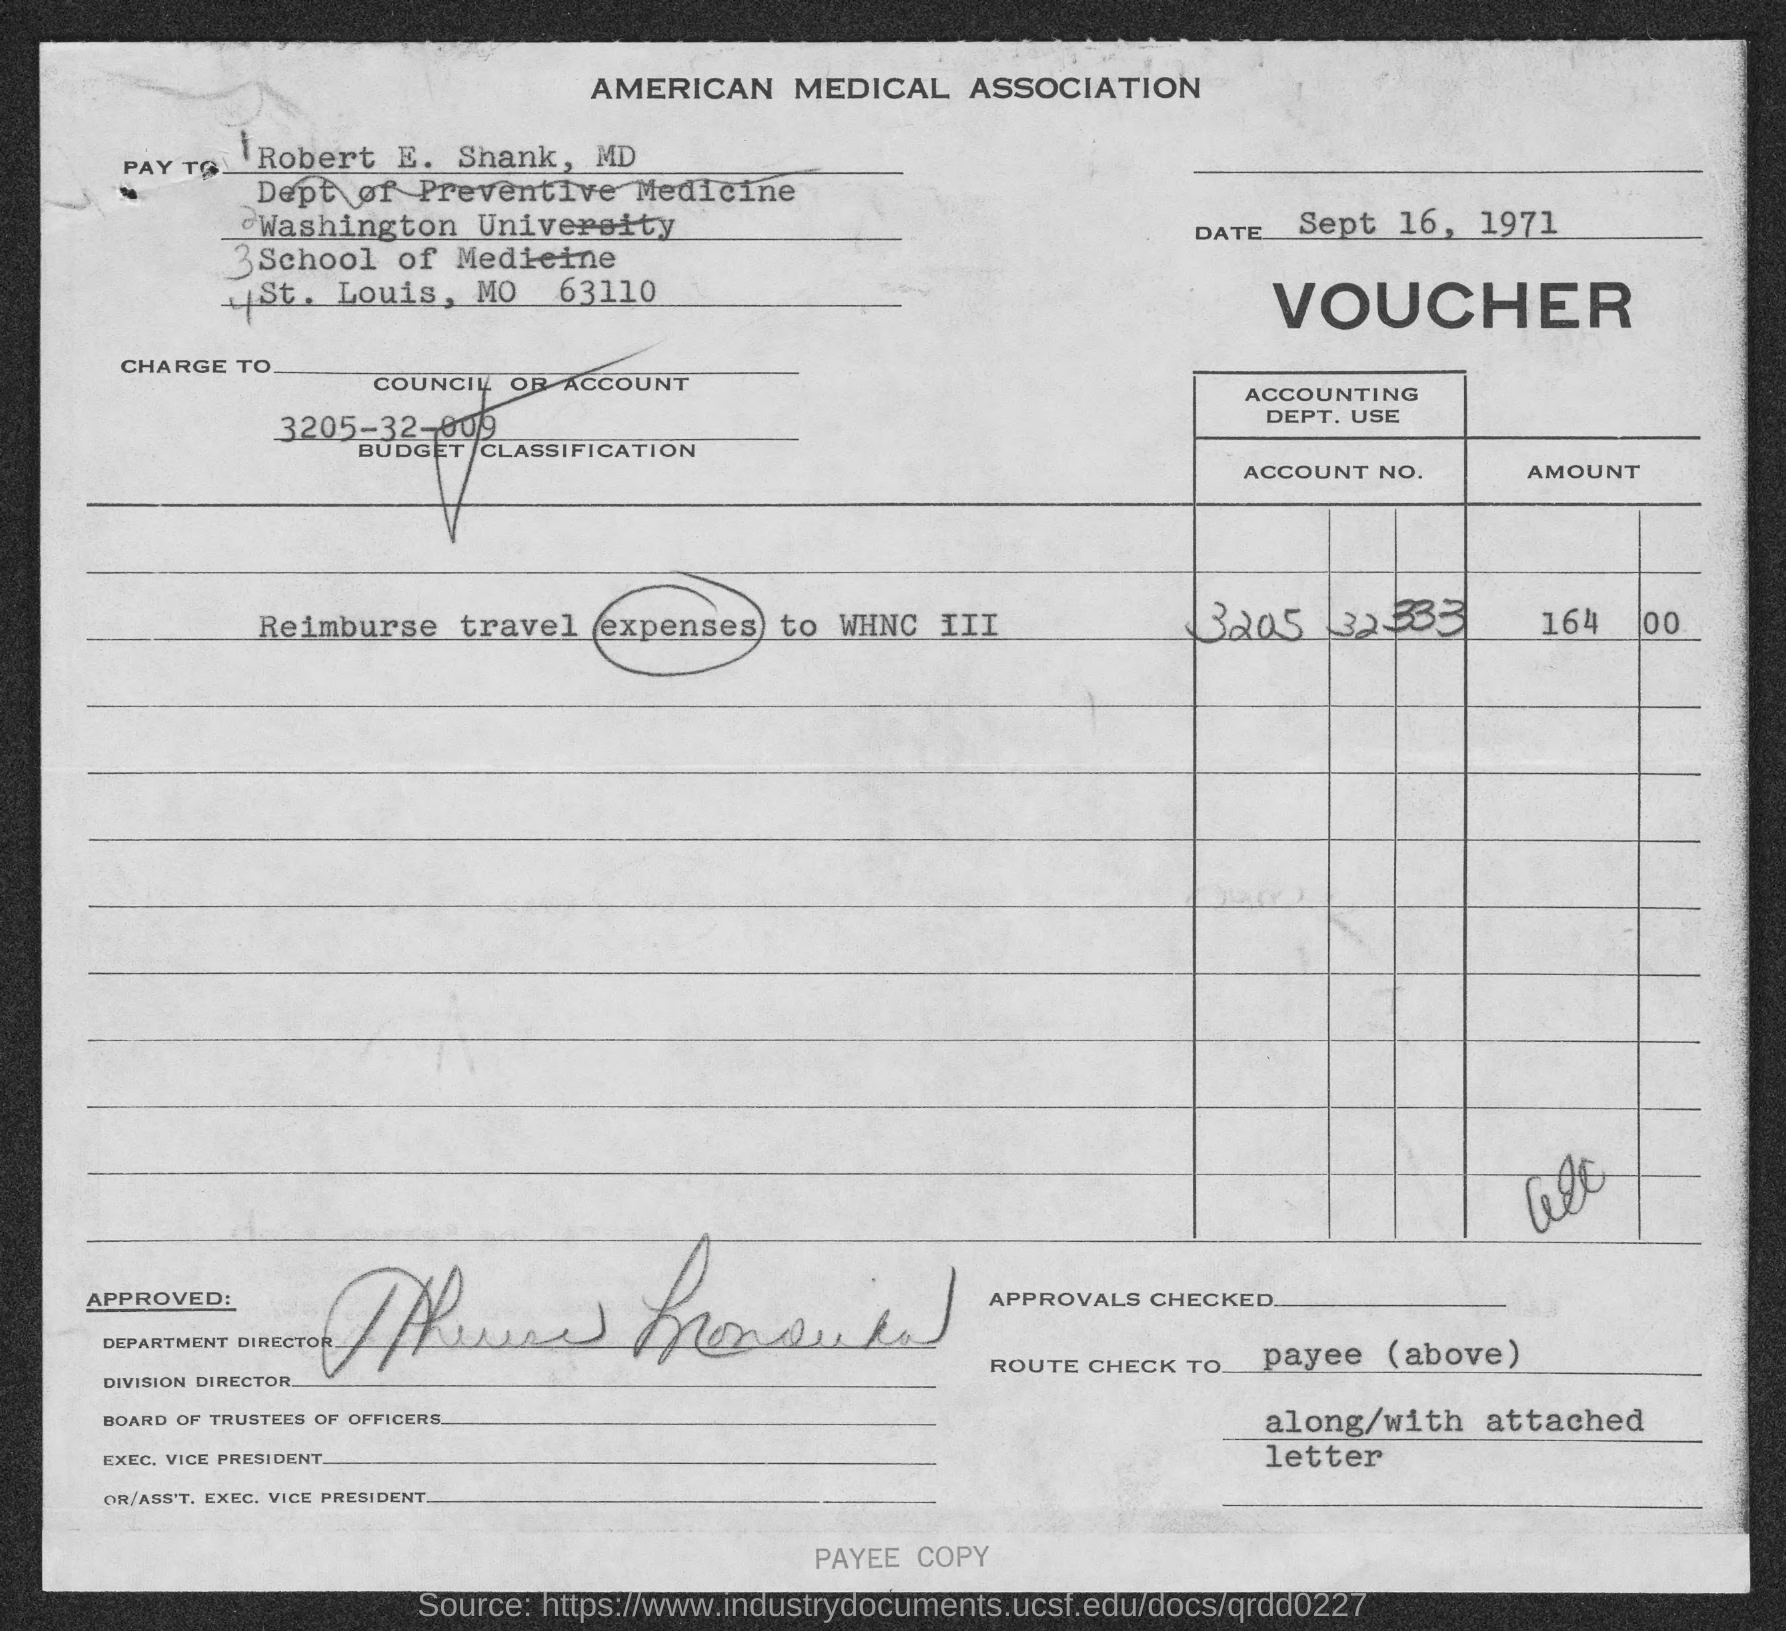Outline some significant characteristics in this image. The memorandum is dated September 16, 1971. 